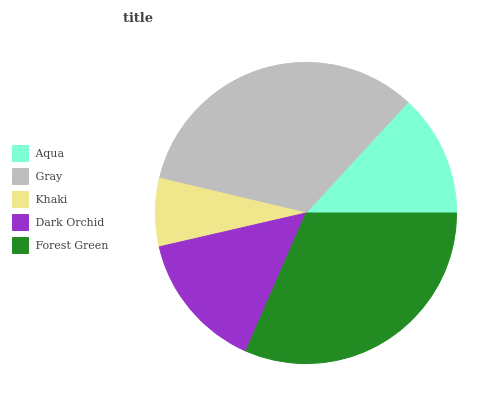Is Khaki the minimum?
Answer yes or no. Yes. Is Gray the maximum?
Answer yes or no. Yes. Is Gray the minimum?
Answer yes or no. No. Is Khaki the maximum?
Answer yes or no. No. Is Gray greater than Khaki?
Answer yes or no. Yes. Is Khaki less than Gray?
Answer yes or no. Yes. Is Khaki greater than Gray?
Answer yes or no. No. Is Gray less than Khaki?
Answer yes or no. No. Is Dark Orchid the high median?
Answer yes or no. Yes. Is Dark Orchid the low median?
Answer yes or no. Yes. Is Gray the high median?
Answer yes or no. No. Is Aqua the low median?
Answer yes or no. No. 